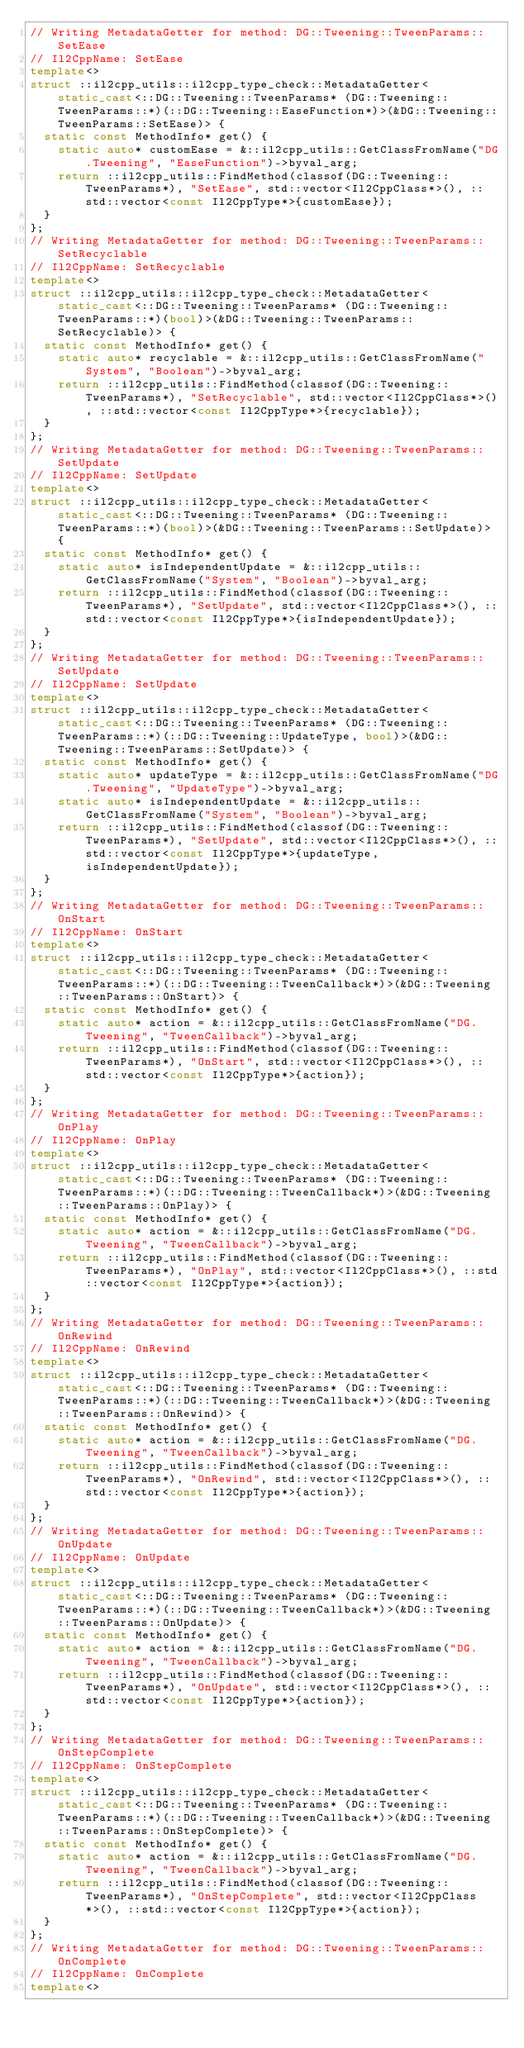Convert code to text. <code><loc_0><loc_0><loc_500><loc_500><_C++_>// Writing MetadataGetter for method: DG::Tweening::TweenParams::SetEase
// Il2CppName: SetEase
template<>
struct ::il2cpp_utils::il2cpp_type_check::MetadataGetter<static_cast<::DG::Tweening::TweenParams* (DG::Tweening::TweenParams::*)(::DG::Tweening::EaseFunction*)>(&DG::Tweening::TweenParams::SetEase)> {
  static const MethodInfo* get() {
    static auto* customEase = &::il2cpp_utils::GetClassFromName("DG.Tweening", "EaseFunction")->byval_arg;
    return ::il2cpp_utils::FindMethod(classof(DG::Tweening::TweenParams*), "SetEase", std::vector<Il2CppClass*>(), ::std::vector<const Il2CppType*>{customEase});
  }
};
// Writing MetadataGetter for method: DG::Tweening::TweenParams::SetRecyclable
// Il2CppName: SetRecyclable
template<>
struct ::il2cpp_utils::il2cpp_type_check::MetadataGetter<static_cast<::DG::Tweening::TweenParams* (DG::Tweening::TweenParams::*)(bool)>(&DG::Tweening::TweenParams::SetRecyclable)> {
  static const MethodInfo* get() {
    static auto* recyclable = &::il2cpp_utils::GetClassFromName("System", "Boolean")->byval_arg;
    return ::il2cpp_utils::FindMethod(classof(DG::Tweening::TweenParams*), "SetRecyclable", std::vector<Il2CppClass*>(), ::std::vector<const Il2CppType*>{recyclable});
  }
};
// Writing MetadataGetter for method: DG::Tweening::TweenParams::SetUpdate
// Il2CppName: SetUpdate
template<>
struct ::il2cpp_utils::il2cpp_type_check::MetadataGetter<static_cast<::DG::Tweening::TweenParams* (DG::Tweening::TweenParams::*)(bool)>(&DG::Tweening::TweenParams::SetUpdate)> {
  static const MethodInfo* get() {
    static auto* isIndependentUpdate = &::il2cpp_utils::GetClassFromName("System", "Boolean")->byval_arg;
    return ::il2cpp_utils::FindMethod(classof(DG::Tweening::TweenParams*), "SetUpdate", std::vector<Il2CppClass*>(), ::std::vector<const Il2CppType*>{isIndependentUpdate});
  }
};
// Writing MetadataGetter for method: DG::Tweening::TweenParams::SetUpdate
// Il2CppName: SetUpdate
template<>
struct ::il2cpp_utils::il2cpp_type_check::MetadataGetter<static_cast<::DG::Tweening::TweenParams* (DG::Tweening::TweenParams::*)(::DG::Tweening::UpdateType, bool)>(&DG::Tweening::TweenParams::SetUpdate)> {
  static const MethodInfo* get() {
    static auto* updateType = &::il2cpp_utils::GetClassFromName("DG.Tweening", "UpdateType")->byval_arg;
    static auto* isIndependentUpdate = &::il2cpp_utils::GetClassFromName("System", "Boolean")->byval_arg;
    return ::il2cpp_utils::FindMethod(classof(DG::Tweening::TweenParams*), "SetUpdate", std::vector<Il2CppClass*>(), ::std::vector<const Il2CppType*>{updateType, isIndependentUpdate});
  }
};
// Writing MetadataGetter for method: DG::Tweening::TweenParams::OnStart
// Il2CppName: OnStart
template<>
struct ::il2cpp_utils::il2cpp_type_check::MetadataGetter<static_cast<::DG::Tweening::TweenParams* (DG::Tweening::TweenParams::*)(::DG::Tweening::TweenCallback*)>(&DG::Tweening::TweenParams::OnStart)> {
  static const MethodInfo* get() {
    static auto* action = &::il2cpp_utils::GetClassFromName("DG.Tweening", "TweenCallback")->byval_arg;
    return ::il2cpp_utils::FindMethod(classof(DG::Tweening::TweenParams*), "OnStart", std::vector<Il2CppClass*>(), ::std::vector<const Il2CppType*>{action});
  }
};
// Writing MetadataGetter for method: DG::Tweening::TweenParams::OnPlay
// Il2CppName: OnPlay
template<>
struct ::il2cpp_utils::il2cpp_type_check::MetadataGetter<static_cast<::DG::Tweening::TweenParams* (DG::Tweening::TweenParams::*)(::DG::Tweening::TweenCallback*)>(&DG::Tweening::TweenParams::OnPlay)> {
  static const MethodInfo* get() {
    static auto* action = &::il2cpp_utils::GetClassFromName("DG.Tweening", "TweenCallback")->byval_arg;
    return ::il2cpp_utils::FindMethod(classof(DG::Tweening::TweenParams*), "OnPlay", std::vector<Il2CppClass*>(), ::std::vector<const Il2CppType*>{action});
  }
};
// Writing MetadataGetter for method: DG::Tweening::TweenParams::OnRewind
// Il2CppName: OnRewind
template<>
struct ::il2cpp_utils::il2cpp_type_check::MetadataGetter<static_cast<::DG::Tweening::TweenParams* (DG::Tweening::TweenParams::*)(::DG::Tweening::TweenCallback*)>(&DG::Tweening::TweenParams::OnRewind)> {
  static const MethodInfo* get() {
    static auto* action = &::il2cpp_utils::GetClassFromName("DG.Tweening", "TweenCallback")->byval_arg;
    return ::il2cpp_utils::FindMethod(classof(DG::Tweening::TweenParams*), "OnRewind", std::vector<Il2CppClass*>(), ::std::vector<const Il2CppType*>{action});
  }
};
// Writing MetadataGetter for method: DG::Tweening::TweenParams::OnUpdate
// Il2CppName: OnUpdate
template<>
struct ::il2cpp_utils::il2cpp_type_check::MetadataGetter<static_cast<::DG::Tweening::TweenParams* (DG::Tweening::TweenParams::*)(::DG::Tweening::TweenCallback*)>(&DG::Tweening::TweenParams::OnUpdate)> {
  static const MethodInfo* get() {
    static auto* action = &::il2cpp_utils::GetClassFromName("DG.Tweening", "TweenCallback")->byval_arg;
    return ::il2cpp_utils::FindMethod(classof(DG::Tweening::TweenParams*), "OnUpdate", std::vector<Il2CppClass*>(), ::std::vector<const Il2CppType*>{action});
  }
};
// Writing MetadataGetter for method: DG::Tweening::TweenParams::OnStepComplete
// Il2CppName: OnStepComplete
template<>
struct ::il2cpp_utils::il2cpp_type_check::MetadataGetter<static_cast<::DG::Tweening::TweenParams* (DG::Tweening::TweenParams::*)(::DG::Tweening::TweenCallback*)>(&DG::Tweening::TweenParams::OnStepComplete)> {
  static const MethodInfo* get() {
    static auto* action = &::il2cpp_utils::GetClassFromName("DG.Tweening", "TweenCallback")->byval_arg;
    return ::il2cpp_utils::FindMethod(classof(DG::Tweening::TweenParams*), "OnStepComplete", std::vector<Il2CppClass*>(), ::std::vector<const Il2CppType*>{action});
  }
};
// Writing MetadataGetter for method: DG::Tweening::TweenParams::OnComplete
// Il2CppName: OnComplete
template<></code> 